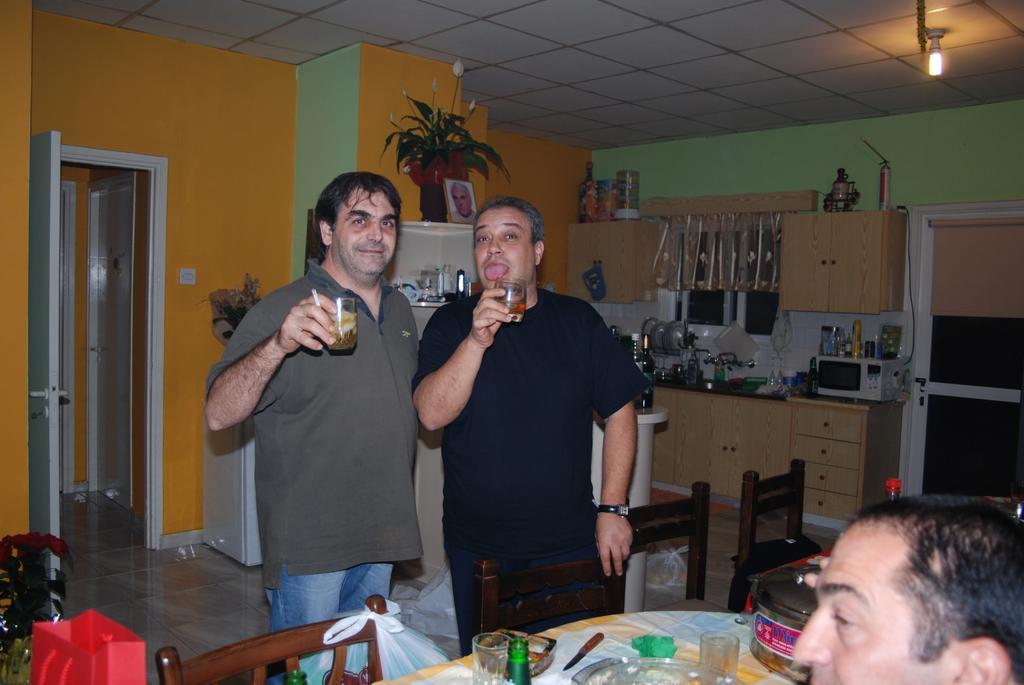Could you give a brief overview of what you see in this image? There are two persons standing and holding a wine bottle in their hands and there is a table in front of them which has some eatables on it and there is other person in the right corner. 